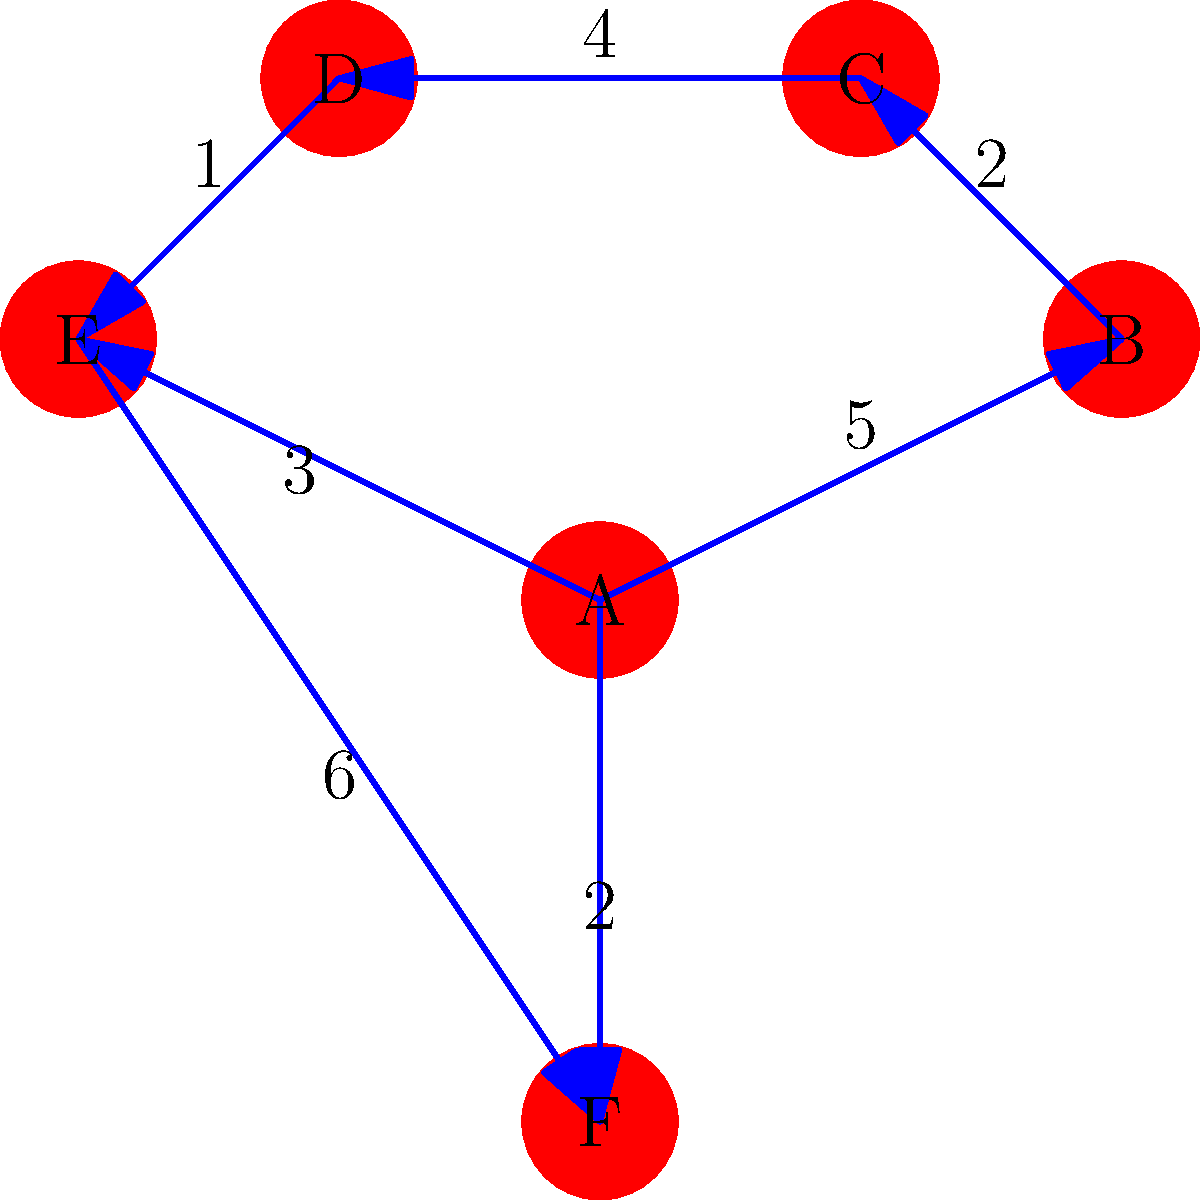In the library's internal network, represented by the weighted graph above, what is the shortest path from node A to node D, and what is its total weight? To find the shortest path from node A to node D, we'll use Dijkstra's algorithm:

1. Initialize:
   - Set A's distance to 0, all others to infinity.
   - Set all nodes as unvisited.

2. Start from node A:
   - Update neighbors: B (5), E (3), F (2)
   - Mark A as visited

3. Choose the unvisited node with smallest distance (F, 2):
   - Update neighbor E: min(infinity, 2 + 6) = 8
   - Mark F as visited

4. Choose the unvisited node with smallest distance (E, 3):
   - Update neighbor D: min(infinity, 3 + 1) = 4
   - Mark E as visited

5. Choose the unvisited node with smallest distance (D, 4):
   - No unvisited neighbors
   - Mark D as visited

6. We've reached D, so we stop.

The shortest path is A → E → D with a total weight of 3 + 1 = 4.
Answer: A → E → D, weight 4 